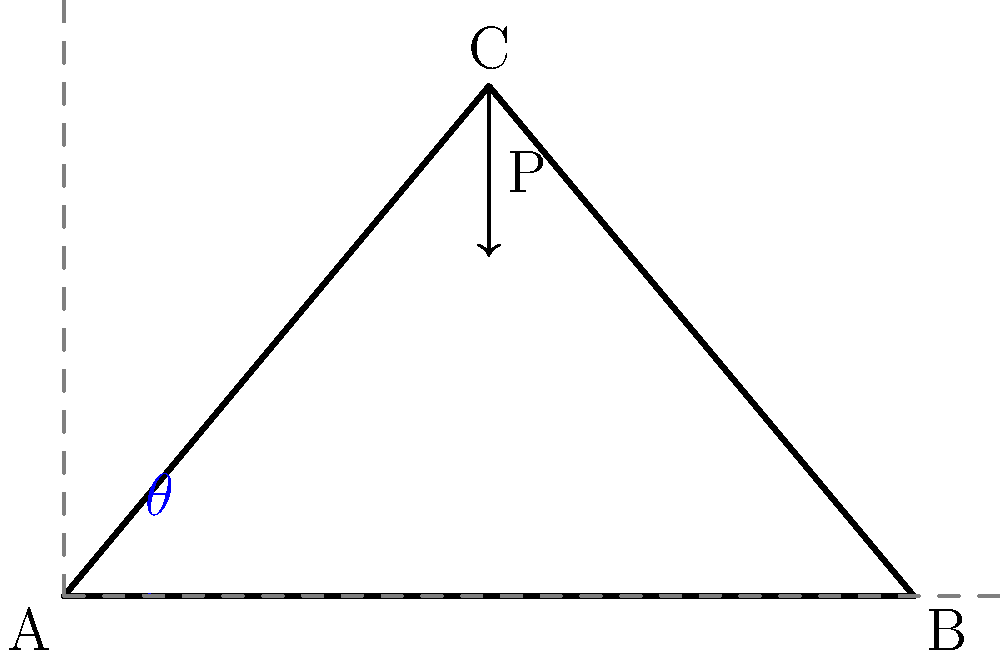In the truss structure shown above, a vertical load P is applied at point C. Given that the span AB is 100 units and the height of the truss at C is 60 units, determine the optimal angle $\theta$ (in degrees) that maximizes the efficiency of the truss. Assume that the efficiency is directly related to the ratio of the vertical force component to the total force in the truss members. To determine the optimal angle for the truss, we'll follow these steps:

1) First, we need to understand that the efficiency of the truss is related to the ratio of the vertical force component to the total force in the truss members. This ratio is maximized when the angle is optimal.

2) In a symmetric truss like this, the optimal angle is the one that forms between the horizontal and the truss member (AC or BC).

3) We can calculate this angle using trigonometry:

   $\tan \theta = \frac{\text{opposite}}{\text{adjacent}} = \frac{\text{height}}{\frac{1}{2}\text{span}}$

4) We're given:
   - Height of the truss (BC) = 60 units
   - Span (AB) = 100 units

5) Plugging these into our equation:

   $\tan \theta = \frac{60}{\frac{1}{2}(100)} = \frac{60}{50} = 1.2$

6) To get the angle, we need to take the inverse tangent (arctangent):

   $\theta = \tan^{-1}(1.2)$

7) Using a calculator or programming function:

   $\theta \approx 50.2°$

This angle maximizes the efficiency of the truss by optimizing the balance between the vertical and horizontal force components in the truss members.
Answer: $50.2°$ 